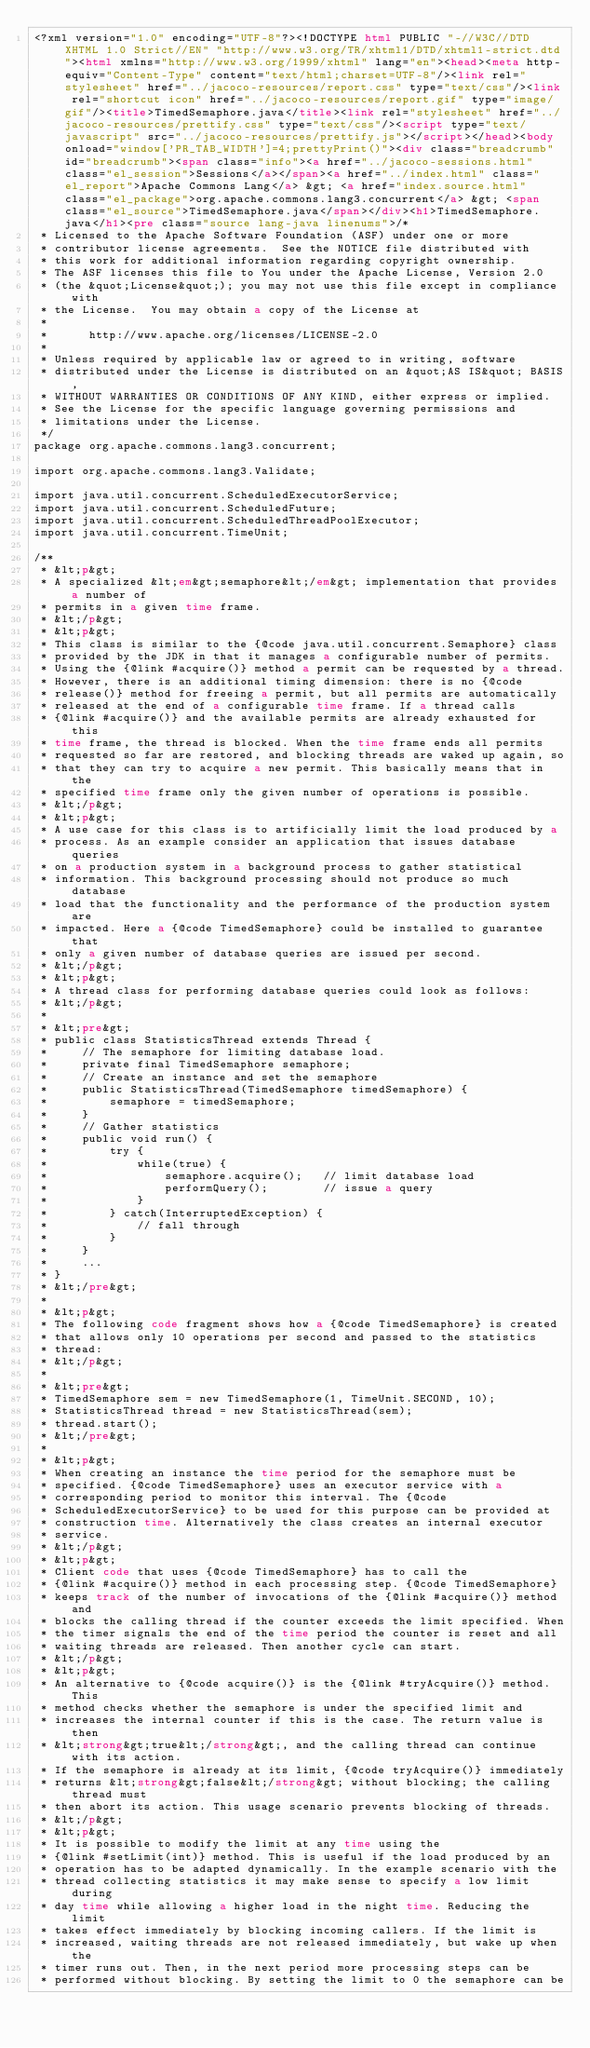<code> <loc_0><loc_0><loc_500><loc_500><_HTML_><?xml version="1.0" encoding="UTF-8"?><!DOCTYPE html PUBLIC "-//W3C//DTD XHTML 1.0 Strict//EN" "http://www.w3.org/TR/xhtml1/DTD/xhtml1-strict.dtd"><html xmlns="http://www.w3.org/1999/xhtml" lang="en"><head><meta http-equiv="Content-Type" content="text/html;charset=UTF-8"/><link rel="stylesheet" href="../jacoco-resources/report.css" type="text/css"/><link rel="shortcut icon" href="../jacoco-resources/report.gif" type="image/gif"/><title>TimedSemaphore.java</title><link rel="stylesheet" href="../jacoco-resources/prettify.css" type="text/css"/><script type="text/javascript" src="../jacoco-resources/prettify.js"></script></head><body onload="window['PR_TAB_WIDTH']=4;prettyPrint()"><div class="breadcrumb" id="breadcrumb"><span class="info"><a href="../jacoco-sessions.html" class="el_session">Sessions</a></span><a href="../index.html" class="el_report">Apache Commons Lang</a> &gt; <a href="index.source.html" class="el_package">org.apache.commons.lang3.concurrent</a> &gt; <span class="el_source">TimedSemaphore.java</span></div><h1>TimedSemaphore.java</h1><pre class="source lang-java linenums">/*
 * Licensed to the Apache Software Foundation (ASF) under one or more
 * contributor license agreements.  See the NOTICE file distributed with
 * this work for additional information regarding copyright ownership.
 * The ASF licenses this file to You under the Apache License, Version 2.0
 * (the &quot;License&quot;); you may not use this file except in compliance with
 * the License.  You may obtain a copy of the License at
 *
 *      http://www.apache.org/licenses/LICENSE-2.0
 *
 * Unless required by applicable law or agreed to in writing, software
 * distributed under the License is distributed on an &quot;AS IS&quot; BASIS,
 * WITHOUT WARRANTIES OR CONDITIONS OF ANY KIND, either express or implied.
 * See the License for the specific language governing permissions and
 * limitations under the License.
 */
package org.apache.commons.lang3.concurrent;

import org.apache.commons.lang3.Validate;

import java.util.concurrent.ScheduledExecutorService;
import java.util.concurrent.ScheduledFuture;
import java.util.concurrent.ScheduledThreadPoolExecutor;
import java.util.concurrent.TimeUnit;

/**
 * &lt;p&gt;
 * A specialized &lt;em&gt;semaphore&lt;/em&gt; implementation that provides a number of
 * permits in a given time frame.
 * &lt;/p&gt;
 * &lt;p&gt;
 * This class is similar to the {@code java.util.concurrent.Semaphore} class
 * provided by the JDK in that it manages a configurable number of permits.
 * Using the {@link #acquire()} method a permit can be requested by a thread.
 * However, there is an additional timing dimension: there is no {@code
 * release()} method for freeing a permit, but all permits are automatically
 * released at the end of a configurable time frame. If a thread calls
 * {@link #acquire()} and the available permits are already exhausted for this
 * time frame, the thread is blocked. When the time frame ends all permits
 * requested so far are restored, and blocking threads are waked up again, so
 * that they can try to acquire a new permit. This basically means that in the
 * specified time frame only the given number of operations is possible.
 * &lt;/p&gt;
 * &lt;p&gt;
 * A use case for this class is to artificially limit the load produced by a
 * process. As an example consider an application that issues database queries
 * on a production system in a background process to gather statistical
 * information. This background processing should not produce so much database
 * load that the functionality and the performance of the production system are
 * impacted. Here a {@code TimedSemaphore} could be installed to guarantee that
 * only a given number of database queries are issued per second.
 * &lt;/p&gt;
 * &lt;p&gt;
 * A thread class for performing database queries could look as follows:
 * &lt;/p&gt;
 *
 * &lt;pre&gt;
 * public class StatisticsThread extends Thread {
 *     // The semaphore for limiting database load.
 *     private final TimedSemaphore semaphore;
 *     // Create an instance and set the semaphore
 *     public StatisticsThread(TimedSemaphore timedSemaphore) {
 *         semaphore = timedSemaphore;
 *     }
 *     // Gather statistics
 *     public void run() {
 *         try {
 *             while(true) {
 *                 semaphore.acquire();   // limit database load
 *                 performQuery();        // issue a query
 *             }
 *         } catch(InterruptedException) {
 *             // fall through
 *         }
 *     }
 *     ...
 * }
 * &lt;/pre&gt;
 *
 * &lt;p&gt;
 * The following code fragment shows how a {@code TimedSemaphore} is created
 * that allows only 10 operations per second and passed to the statistics
 * thread:
 * &lt;/p&gt;
 *
 * &lt;pre&gt;
 * TimedSemaphore sem = new TimedSemaphore(1, TimeUnit.SECOND, 10);
 * StatisticsThread thread = new StatisticsThread(sem);
 * thread.start();
 * &lt;/pre&gt;
 *
 * &lt;p&gt;
 * When creating an instance the time period for the semaphore must be
 * specified. {@code TimedSemaphore} uses an executor service with a
 * corresponding period to monitor this interval. The {@code
 * ScheduledExecutorService} to be used for this purpose can be provided at
 * construction time. Alternatively the class creates an internal executor
 * service.
 * &lt;/p&gt;
 * &lt;p&gt;
 * Client code that uses {@code TimedSemaphore} has to call the
 * {@link #acquire()} method in each processing step. {@code TimedSemaphore}
 * keeps track of the number of invocations of the {@link #acquire()} method and
 * blocks the calling thread if the counter exceeds the limit specified. When
 * the timer signals the end of the time period the counter is reset and all
 * waiting threads are released. Then another cycle can start.
 * &lt;/p&gt;
 * &lt;p&gt;
 * An alternative to {@code acquire()} is the {@link #tryAcquire()} method. This
 * method checks whether the semaphore is under the specified limit and
 * increases the internal counter if this is the case. The return value is then
 * &lt;strong&gt;true&lt;/strong&gt;, and the calling thread can continue with its action.
 * If the semaphore is already at its limit, {@code tryAcquire()} immediately
 * returns &lt;strong&gt;false&lt;/strong&gt; without blocking; the calling thread must
 * then abort its action. This usage scenario prevents blocking of threads.
 * &lt;/p&gt;
 * &lt;p&gt;
 * It is possible to modify the limit at any time using the
 * {@link #setLimit(int)} method. This is useful if the load produced by an
 * operation has to be adapted dynamically. In the example scenario with the
 * thread collecting statistics it may make sense to specify a low limit during
 * day time while allowing a higher load in the night time. Reducing the limit
 * takes effect immediately by blocking incoming callers. If the limit is
 * increased, waiting threads are not released immediately, but wake up when the
 * timer runs out. Then, in the next period more processing steps can be
 * performed without blocking. By setting the limit to 0 the semaphore can be</code> 